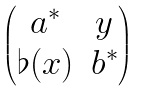<formula> <loc_0><loc_0><loc_500><loc_500>\begin{pmatrix} a ^ { * } & y \\ \flat ( x ) & b ^ { * } \end{pmatrix}</formula> 